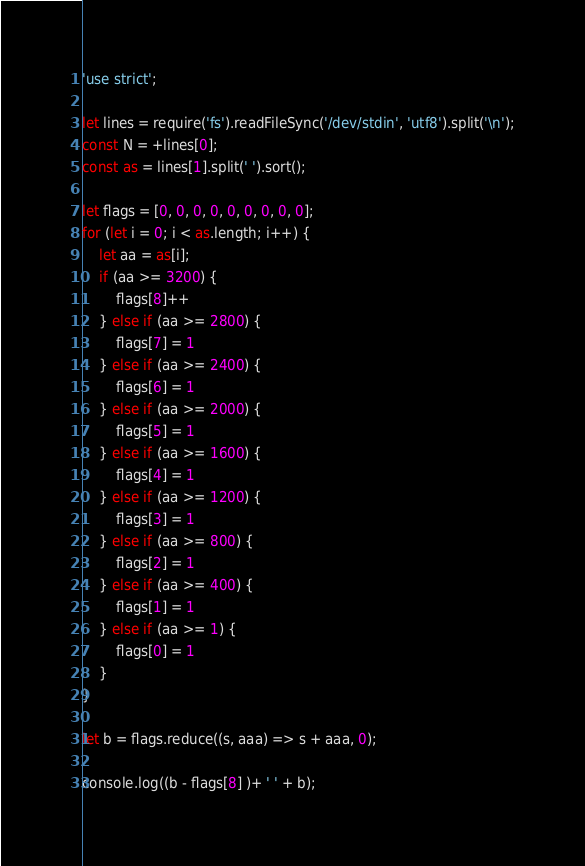<code> <loc_0><loc_0><loc_500><loc_500><_JavaScript_>'use strict';

let lines = require('fs').readFileSync('/dev/stdin', 'utf8').split('\n');
const N = +lines[0];
const as = lines[1].split(' ').sort();

let flags = [0, 0, 0, 0, 0, 0, 0, 0, 0];
for (let i = 0; i < as.length; i++) {
    let aa = as[i];
    if (aa >= 3200) {
        flags[8]++
    } else if (aa >= 2800) {
        flags[7] = 1
    } else if (aa >= 2400) {
        flags[6] = 1
    } else if (aa >= 2000) {
        flags[5] = 1
    } else if (aa >= 1600) {
        flags[4] = 1
    } else if (aa >= 1200) {
        flags[3] = 1
    } else if (aa >= 800) {
        flags[2] = 1
    } else if (aa >= 400) {
        flags[1] = 1
    } else if (aa >= 1) {
        flags[0] = 1
    }
}

let b = flags.reduce((s, aaa) => s + aaa, 0);

console.log((b - flags[8] )+ ' ' + b);</code> 